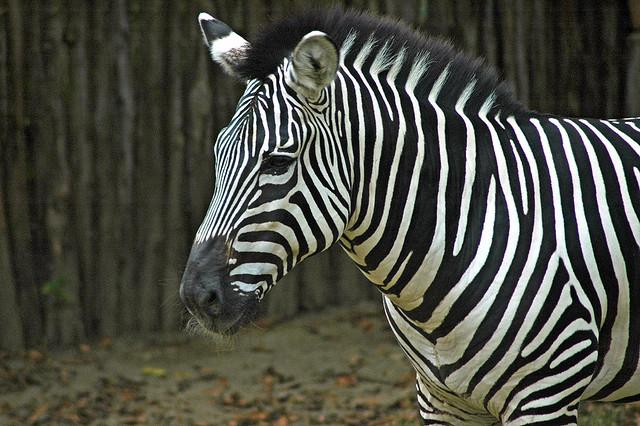Are the zebras stripe black or white?
Be succinct. Both. How many zebra are there?
Short answer required. 1. Is the animal looking at the camera?
Concise answer only. No. Where is the zebra?
Be succinct. Zoo. Does the zebra appear to be showing affection?
Be succinct. No. Is there  more than one zebra?
Quick response, please. No. Do Zebras roll in the grass to clean themselves?
Give a very brief answer. Yes. What kind of hairstyle does the zebra have?
Concise answer only. Mohawk. 